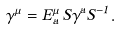<formula> <loc_0><loc_0><loc_500><loc_500>\gamma ^ { \mu } = E ^ { \mu } _ { a } \, S \gamma ^ { a } S ^ { - 1 } .</formula> 